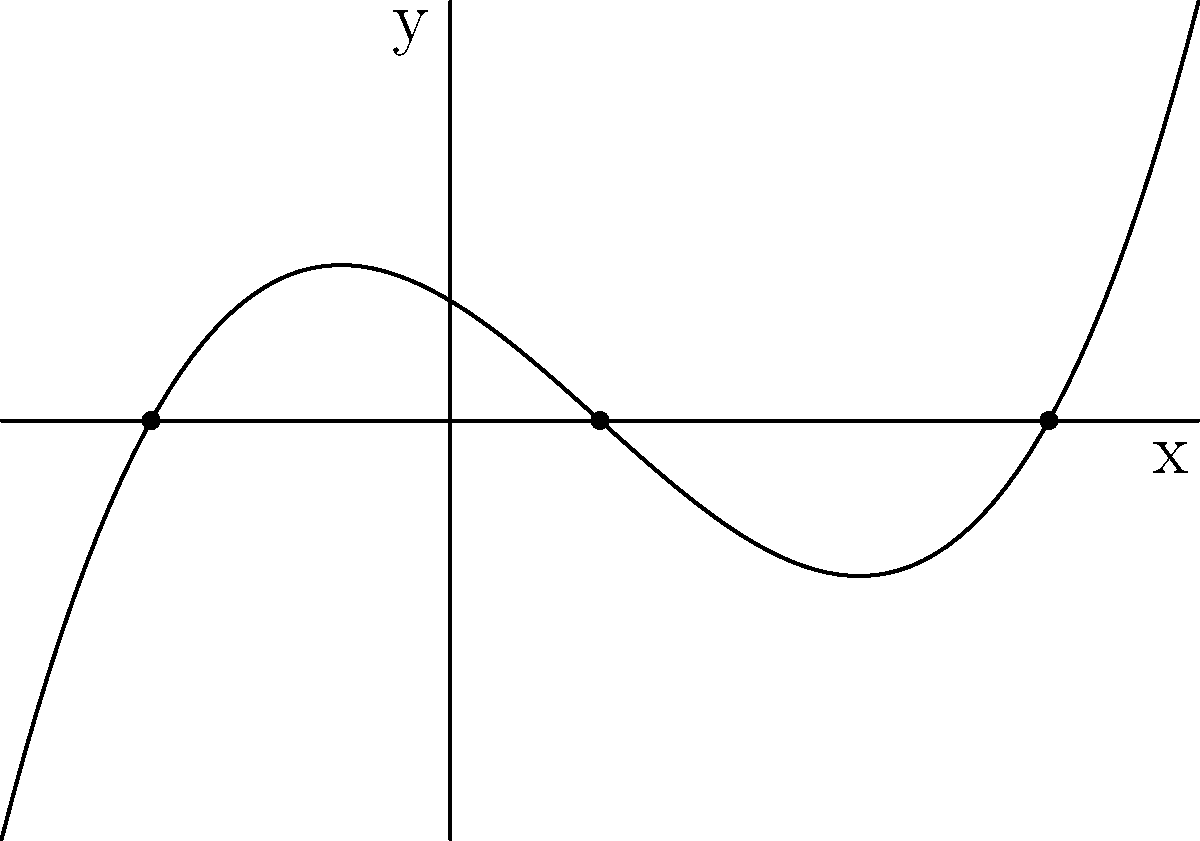A local charity event's fundraising goal can be represented by the polynomial function $f(x) = 0.1(x+2)(x-1)(x-4)$, where $x$ represents the number of weeks since the start of the campaign and $f(x)$ represents the funds raised (in thousands of dollars). Based on the graph, how many weeks will it take for the charity to reach its fundraising goal? To determine how long it will take for the charity to reach its fundraising goal, we need to analyze the roots of the polynomial function:

1. The roots of a polynomial function are the x-intercepts of its graph, where $f(x) = 0$.
2. From the graph, we can see three x-intercepts: $x = -2$, $x = 1$, and $x = 4$.
3. The x-axis represents the number of weeks since the start of the campaign.
4. The y-axis represents the funds raised (in thousands of dollars).
5. The fundraising goal is reached when the graph crosses the x-axis for the last time, which is at $x = 4$.

Therefore, it will take 4 weeks for the charity to reach its fundraising goal.
Answer: 4 weeks 